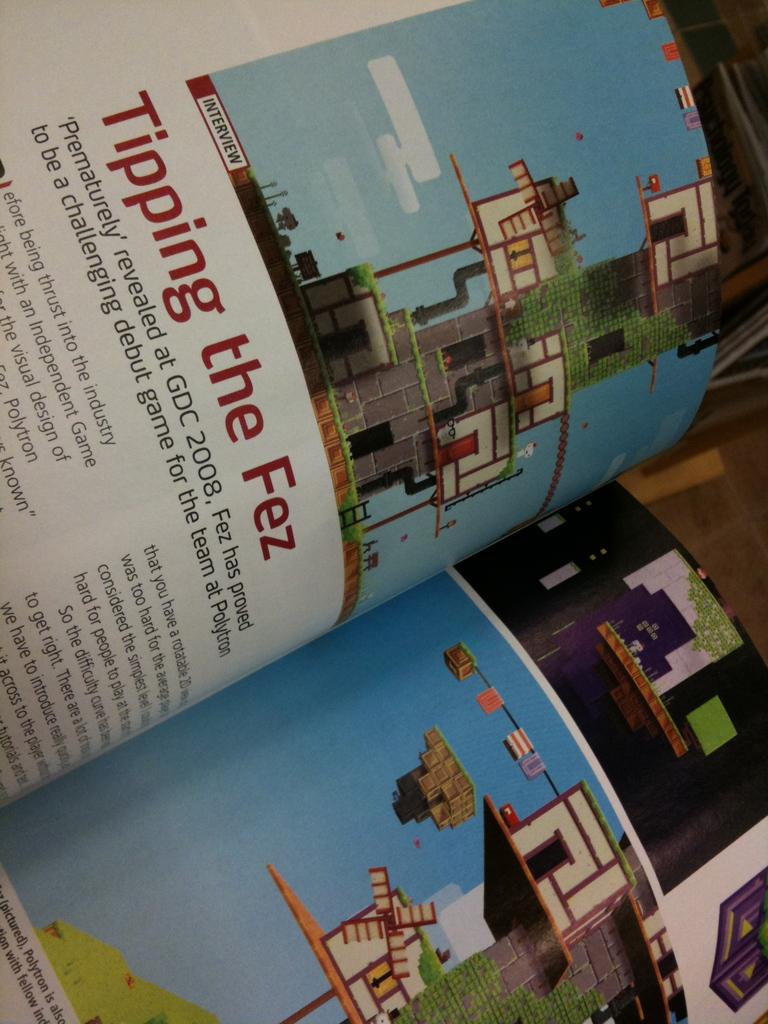<image>
Give a short and clear explanation of the subsequent image. a book with Tipping the Fez inside of it 